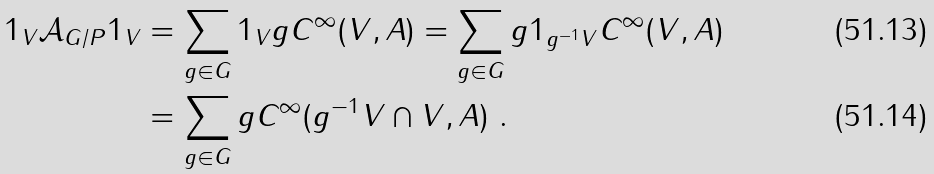<formula> <loc_0><loc_0><loc_500><loc_500>1 _ { V } \mathcal { A } _ { G / P } 1 _ { V } & = \sum _ { g \in G } 1 _ { V } g C ^ { \infty } ( V , A ) = \sum _ { g \in G } g 1 _ { g ^ { - 1 } V } C ^ { \infty } ( V , A ) \\ & = \sum _ { g \in G } g C ^ { \infty } ( g ^ { - 1 } V \cap V , A ) \ .</formula> 